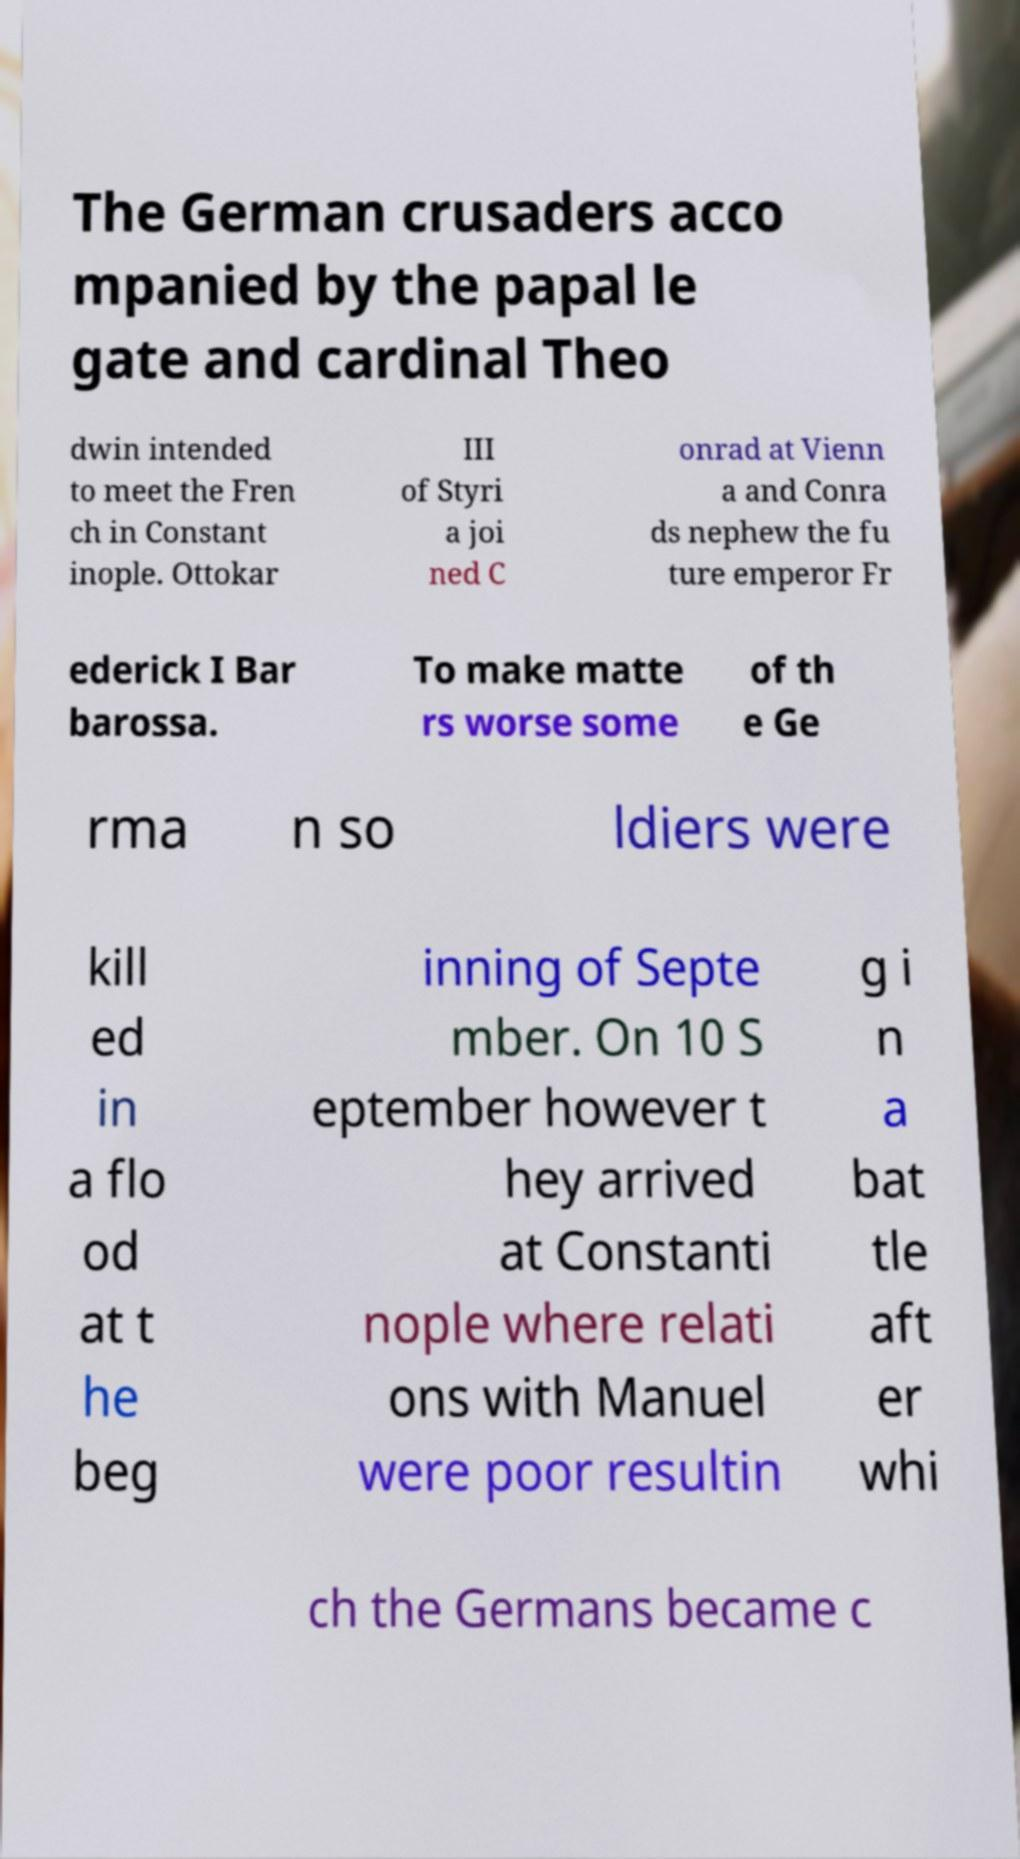Please read and relay the text visible in this image. What does it say? The German crusaders acco mpanied by the papal le gate and cardinal Theo dwin intended to meet the Fren ch in Constant inople. Ottokar III of Styri a joi ned C onrad at Vienn a and Conra ds nephew the fu ture emperor Fr ederick I Bar barossa. To make matte rs worse some of th e Ge rma n so ldiers were kill ed in a flo od at t he beg inning of Septe mber. On 10 S eptember however t hey arrived at Constanti nople where relati ons with Manuel were poor resultin g i n a bat tle aft er whi ch the Germans became c 